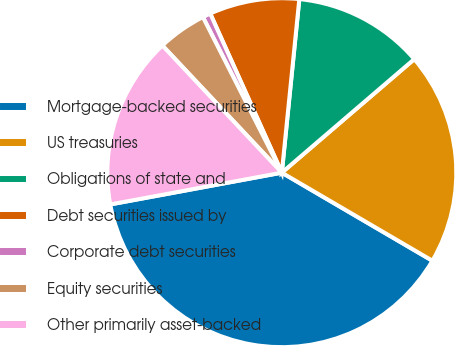<chart> <loc_0><loc_0><loc_500><loc_500><pie_chart><fcel>Mortgage-backed securities<fcel>US treasuries<fcel>Obligations of state and<fcel>Debt securities issued by<fcel>Corporate debt securities<fcel>Equity securities<fcel>Other primarily asset-backed<nl><fcel>38.66%<fcel>19.7%<fcel>12.12%<fcel>8.33%<fcel>0.74%<fcel>4.53%<fcel>15.91%<nl></chart> 